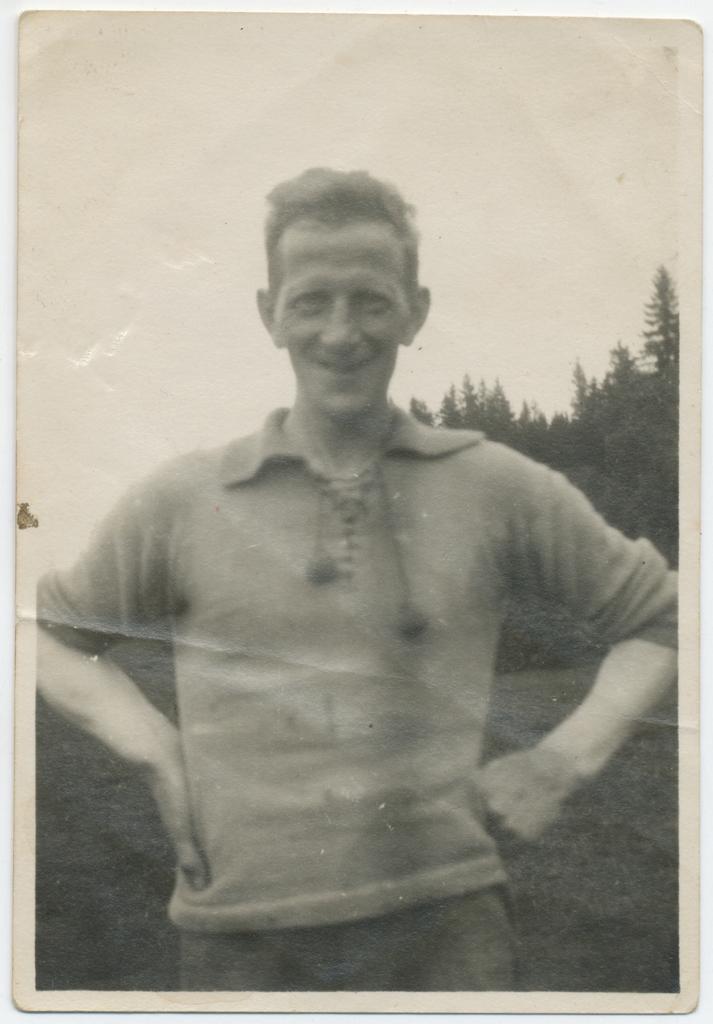Can you describe this image briefly? In the picture we can see an old photograph of a man standing and placing his hands on his hip and he is smiling, behind him we can see a part of the tree and the sky. 